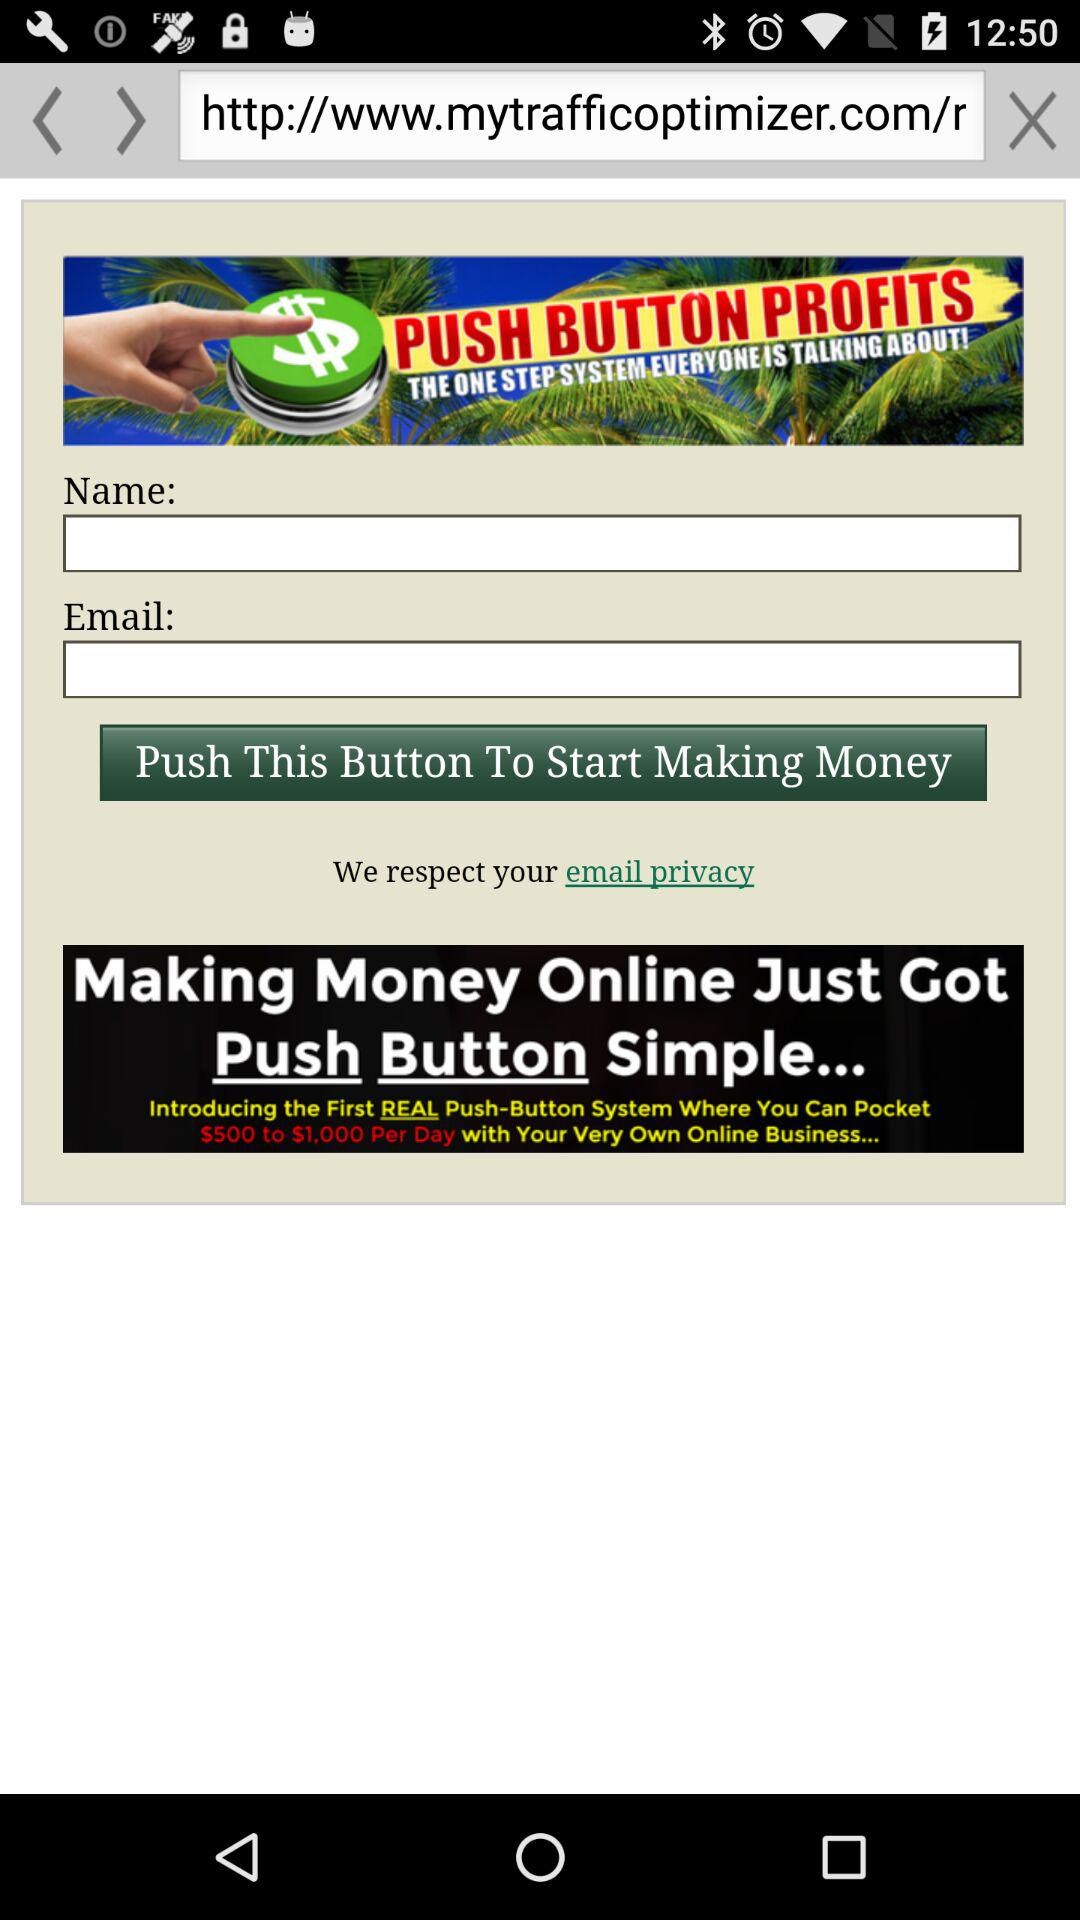How many dollars are you offered to make per day with this system?
Answer the question using a single word or phrase. $500 to $1,000 